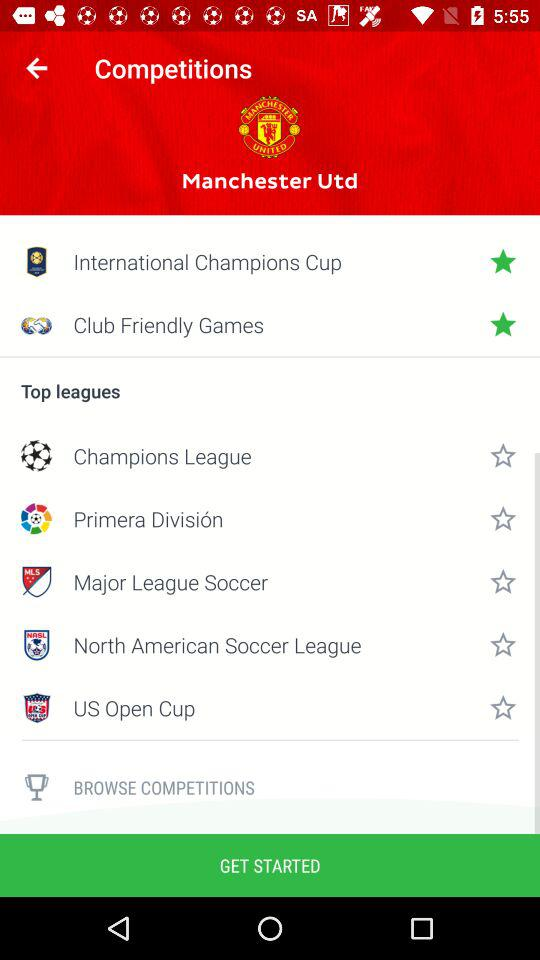Are Club Friendly Games starred?
When the provided information is insufficient, respond with <no answer>. <no answer> 